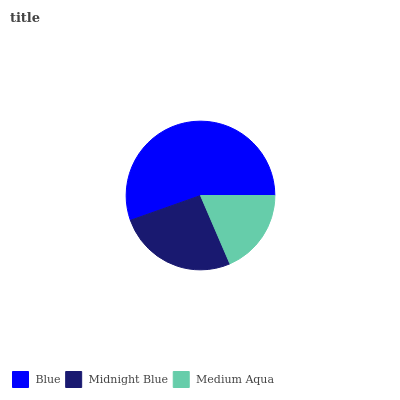Is Medium Aqua the minimum?
Answer yes or no. Yes. Is Blue the maximum?
Answer yes or no. Yes. Is Midnight Blue the minimum?
Answer yes or no. No. Is Midnight Blue the maximum?
Answer yes or no. No. Is Blue greater than Midnight Blue?
Answer yes or no. Yes. Is Midnight Blue less than Blue?
Answer yes or no. Yes. Is Midnight Blue greater than Blue?
Answer yes or no. No. Is Blue less than Midnight Blue?
Answer yes or no. No. Is Midnight Blue the high median?
Answer yes or no. Yes. Is Midnight Blue the low median?
Answer yes or no. Yes. Is Medium Aqua the high median?
Answer yes or no. No. Is Medium Aqua the low median?
Answer yes or no. No. 